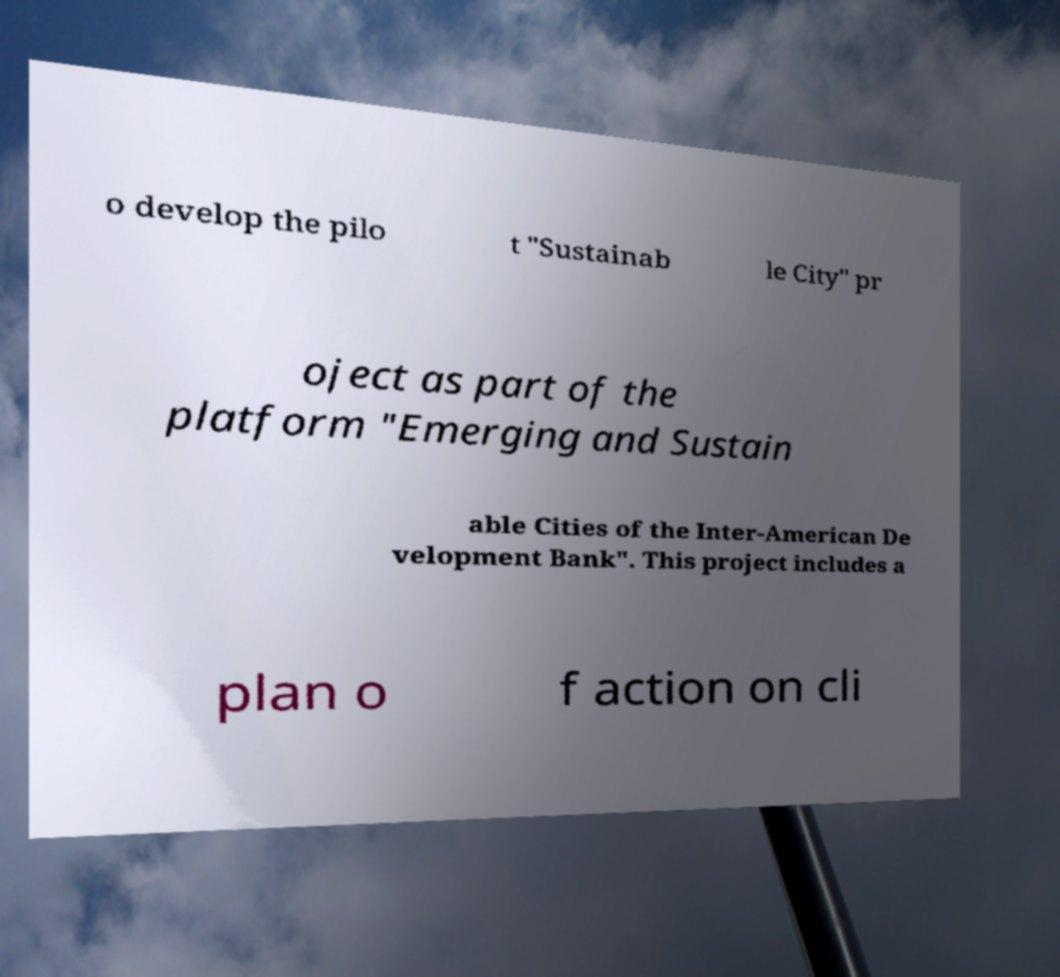Please read and relay the text visible in this image. What does it say? o develop the pilo t "Sustainab le City" pr oject as part of the platform "Emerging and Sustain able Cities of the Inter-American De velopment Bank". This project includes a plan o f action on cli 